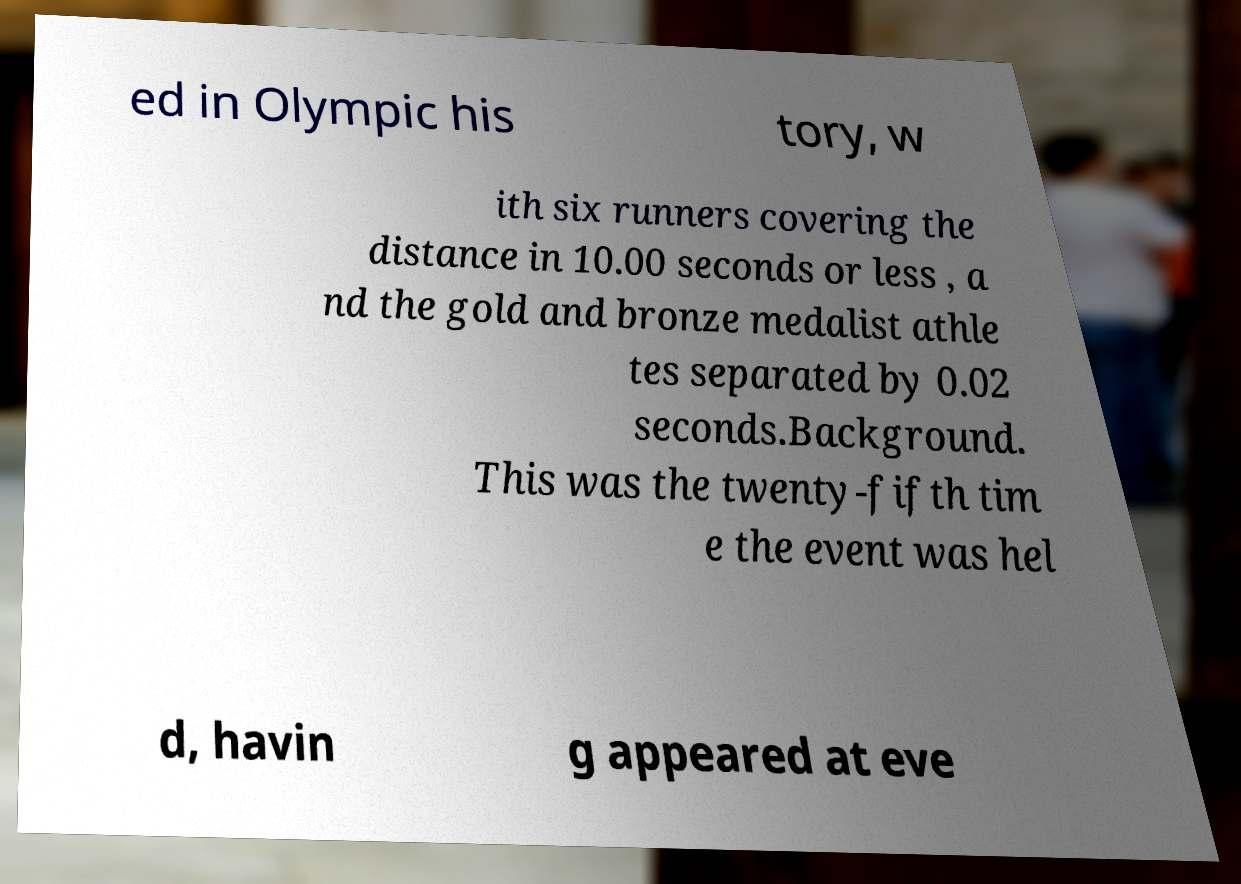Can you read and provide the text displayed in the image?This photo seems to have some interesting text. Can you extract and type it out for me? ed in Olympic his tory, w ith six runners covering the distance in 10.00 seconds or less , a nd the gold and bronze medalist athle tes separated by 0.02 seconds.Background. This was the twenty-fifth tim e the event was hel d, havin g appeared at eve 